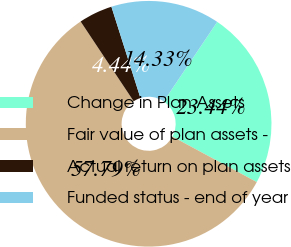Convert chart to OTSL. <chart><loc_0><loc_0><loc_500><loc_500><pie_chart><fcel>Change in Plan Assets<fcel>Fair value of plan assets -<fcel>Actual return on plan assets<fcel>Funded status - end of year<nl><fcel>23.44%<fcel>57.79%<fcel>4.44%<fcel>14.33%<nl></chart> 